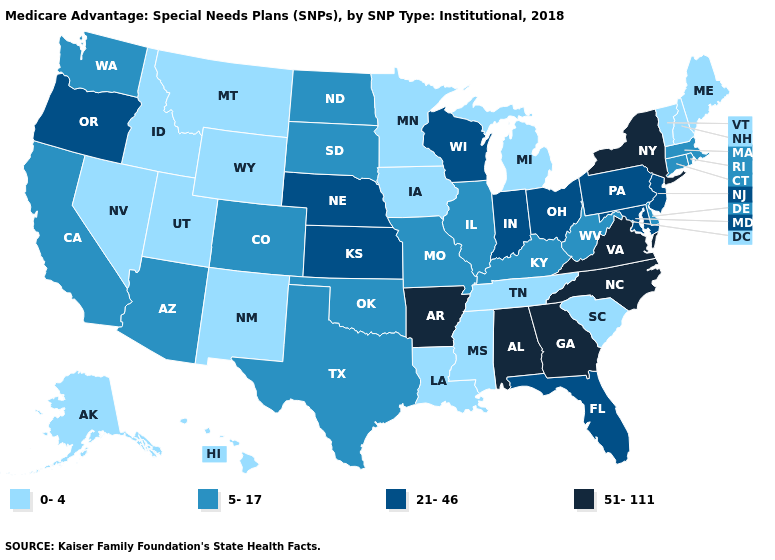Which states have the highest value in the USA?
Write a very short answer. Alabama, Arkansas, Georgia, North Carolina, New York, Virginia. Among the states that border Kentucky , does Virginia have the highest value?
Write a very short answer. Yes. Name the states that have a value in the range 5-17?
Answer briefly. Arizona, California, Colorado, Connecticut, Delaware, Illinois, Kentucky, Massachusetts, Missouri, North Dakota, Oklahoma, Rhode Island, South Dakota, Texas, Washington, West Virginia. Name the states that have a value in the range 0-4?
Answer briefly. Alaska, Hawaii, Iowa, Idaho, Louisiana, Maine, Michigan, Minnesota, Mississippi, Montana, New Hampshire, New Mexico, Nevada, South Carolina, Tennessee, Utah, Vermont, Wyoming. Does Georgia have the lowest value in the USA?
Short answer required. No. Name the states that have a value in the range 21-46?
Concise answer only. Florida, Indiana, Kansas, Maryland, Nebraska, New Jersey, Ohio, Oregon, Pennsylvania, Wisconsin. Is the legend a continuous bar?
Give a very brief answer. No. What is the lowest value in the USA?
Give a very brief answer. 0-4. Does Wyoming have the lowest value in the USA?
Answer briefly. Yes. What is the value of West Virginia?
Be succinct. 5-17. How many symbols are there in the legend?
Answer briefly. 4. What is the value of Washington?
Concise answer only. 5-17. What is the highest value in states that border Alabama?
Give a very brief answer. 51-111. Does the first symbol in the legend represent the smallest category?
Concise answer only. Yes. Does Connecticut have a lower value than Georgia?
Keep it brief. Yes. 